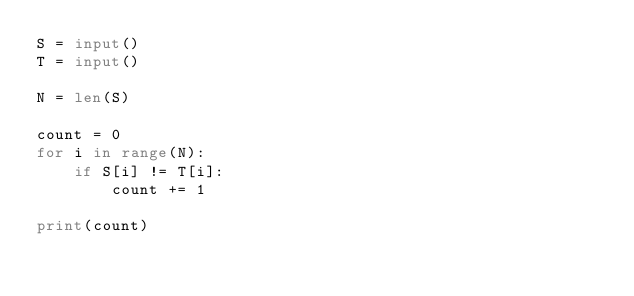<code> <loc_0><loc_0><loc_500><loc_500><_Python_>S = input()
T = input()

N = len(S)

count = 0
for i in range(N):
    if S[i] != T[i]:
        count += 1

print(count)</code> 